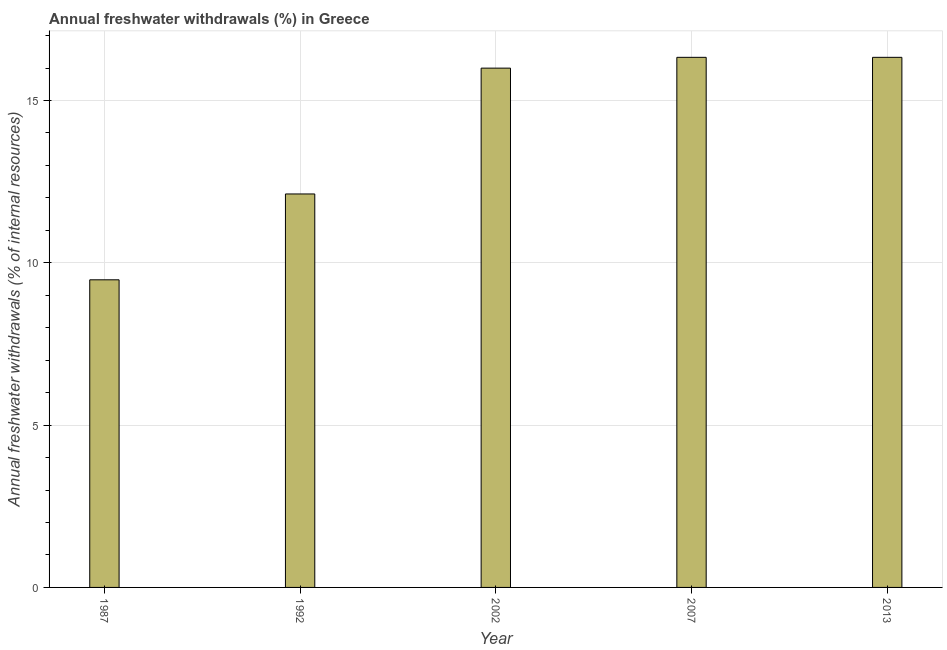Does the graph contain grids?
Your answer should be very brief. Yes. What is the title of the graph?
Give a very brief answer. Annual freshwater withdrawals (%) in Greece. What is the label or title of the Y-axis?
Provide a short and direct response. Annual freshwater withdrawals (% of internal resources). What is the annual freshwater withdrawals in 2002?
Your answer should be compact. 16. Across all years, what is the maximum annual freshwater withdrawals?
Keep it short and to the point. 16.33. Across all years, what is the minimum annual freshwater withdrawals?
Your answer should be very brief. 9.48. In which year was the annual freshwater withdrawals minimum?
Give a very brief answer. 1987. What is the sum of the annual freshwater withdrawals?
Make the answer very short. 70.25. What is the difference between the annual freshwater withdrawals in 1992 and 2002?
Offer a very short reply. -3.88. What is the average annual freshwater withdrawals per year?
Your answer should be very brief. 14.05. What is the median annual freshwater withdrawals?
Provide a short and direct response. 16. Do a majority of the years between 1992 and 2013 (inclusive) have annual freshwater withdrawals greater than 10 %?
Your answer should be very brief. Yes. Is the difference between the annual freshwater withdrawals in 1987 and 1992 greater than the difference between any two years?
Ensure brevity in your answer.  No. What is the difference between the highest and the lowest annual freshwater withdrawals?
Offer a terse response. 6.85. In how many years, is the annual freshwater withdrawals greater than the average annual freshwater withdrawals taken over all years?
Your response must be concise. 3. How many bars are there?
Provide a succinct answer. 5. Are all the bars in the graph horizontal?
Keep it short and to the point. No. How many years are there in the graph?
Give a very brief answer. 5. What is the difference between two consecutive major ticks on the Y-axis?
Your response must be concise. 5. Are the values on the major ticks of Y-axis written in scientific E-notation?
Provide a succinct answer. No. What is the Annual freshwater withdrawals (% of internal resources) of 1987?
Keep it short and to the point. 9.48. What is the Annual freshwater withdrawals (% of internal resources) of 1992?
Your answer should be very brief. 12.12. What is the Annual freshwater withdrawals (% of internal resources) of 2002?
Offer a terse response. 16. What is the Annual freshwater withdrawals (% of internal resources) in 2007?
Offer a very short reply. 16.33. What is the Annual freshwater withdrawals (% of internal resources) of 2013?
Make the answer very short. 16.33. What is the difference between the Annual freshwater withdrawals (% of internal resources) in 1987 and 1992?
Your response must be concise. -2.64. What is the difference between the Annual freshwater withdrawals (% of internal resources) in 1987 and 2002?
Your answer should be compact. -6.52. What is the difference between the Annual freshwater withdrawals (% of internal resources) in 1987 and 2007?
Offer a very short reply. -6.85. What is the difference between the Annual freshwater withdrawals (% of internal resources) in 1987 and 2013?
Make the answer very short. -6.85. What is the difference between the Annual freshwater withdrawals (% of internal resources) in 1992 and 2002?
Your response must be concise. -3.88. What is the difference between the Annual freshwater withdrawals (% of internal resources) in 1992 and 2007?
Ensure brevity in your answer.  -4.21. What is the difference between the Annual freshwater withdrawals (% of internal resources) in 1992 and 2013?
Ensure brevity in your answer.  -4.21. What is the difference between the Annual freshwater withdrawals (% of internal resources) in 2002 and 2007?
Ensure brevity in your answer.  -0.33. What is the difference between the Annual freshwater withdrawals (% of internal resources) in 2002 and 2013?
Ensure brevity in your answer.  -0.33. What is the ratio of the Annual freshwater withdrawals (% of internal resources) in 1987 to that in 1992?
Your answer should be very brief. 0.78. What is the ratio of the Annual freshwater withdrawals (% of internal resources) in 1987 to that in 2002?
Offer a terse response. 0.59. What is the ratio of the Annual freshwater withdrawals (% of internal resources) in 1987 to that in 2007?
Offer a terse response. 0.58. What is the ratio of the Annual freshwater withdrawals (% of internal resources) in 1987 to that in 2013?
Keep it short and to the point. 0.58. What is the ratio of the Annual freshwater withdrawals (% of internal resources) in 1992 to that in 2002?
Give a very brief answer. 0.76. What is the ratio of the Annual freshwater withdrawals (% of internal resources) in 1992 to that in 2007?
Provide a short and direct response. 0.74. What is the ratio of the Annual freshwater withdrawals (% of internal resources) in 1992 to that in 2013?
Ensure brevity in your answer.  0.74. What is the ratio of the Annual freshwater withdrawals (% of internal resources) in 2002 to that in 2007?
Keep it short and to the point. 0.98. 